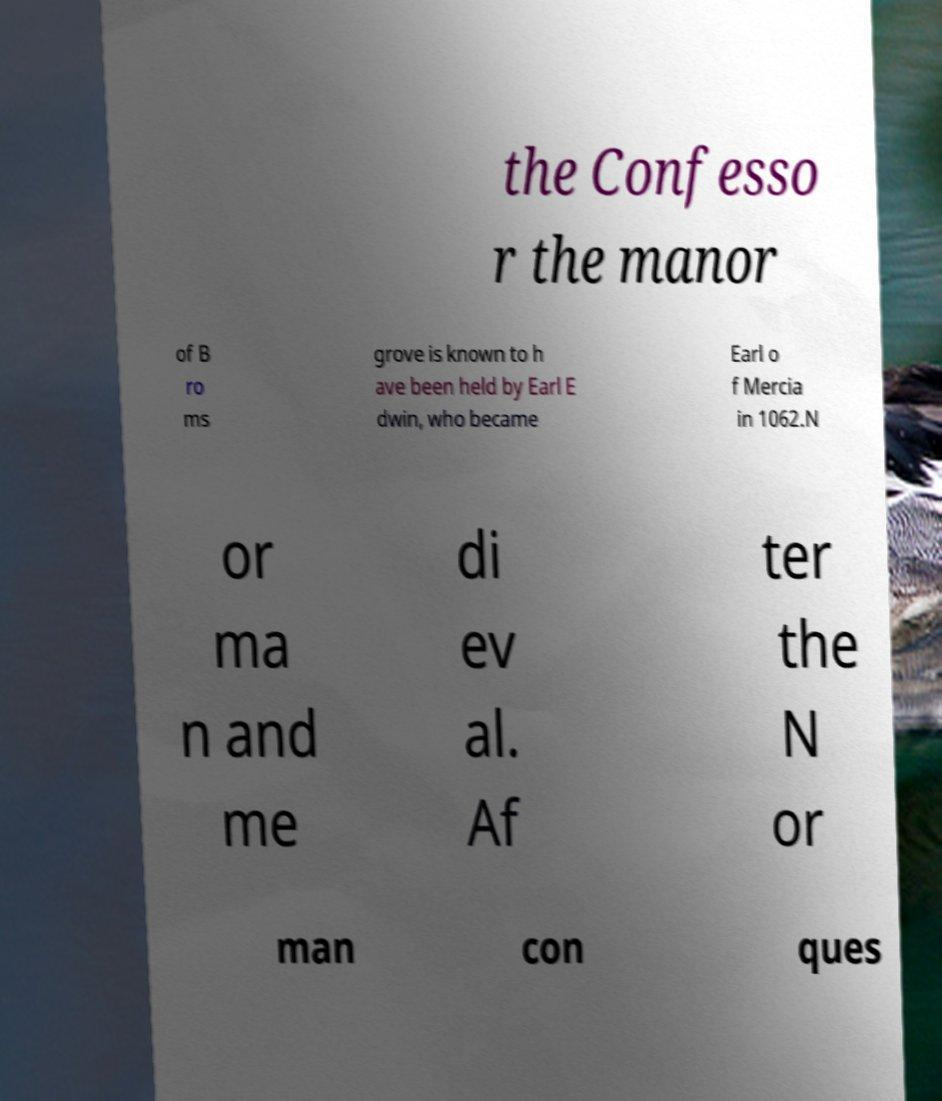Please read and relay the text visible in this image. What does it say? the Confesso r the manor of B ro ms grove is known to h ave been held by Earl E dwin, who became Earl o f Mercia in 1062.N or ma n and me di ev al. Af ter the N or man con ques 